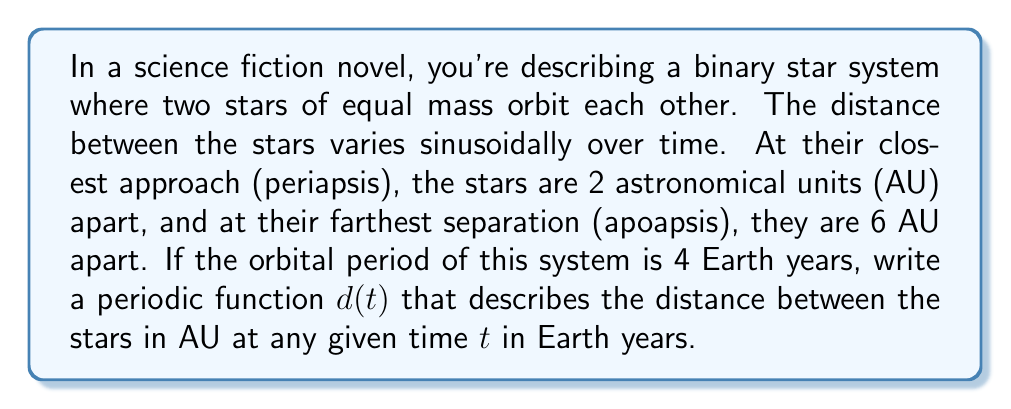Provide a solution to this math problem. To solve this problem, we need to construct a sinusoidal function that represents the distance between the stars over time. Let's approach this step-by-step:

1) The general form of a sinusoidal function is:
   $$d(t) = A \sin(\omega t + \phi) + B$$
   where $A$ is the amplitude, $\omega$ is the angular frequency, $\phi$ is the phase shift, and $B$ is the vertical shift.

2) First, let's determine the vertical shift $B$. This is the midpoint between the maximum and minimum distances:
   $$B = \frac{6 + 2}{2} = 4$$

3) The amplitude $A$ is half the difference between the maximum and minimum distances:
   $$A = \frac{6 - 2}{2} = 2$$

4) The period of the function is 4 years. For a sine function, the period is given by $\frac{2\pi}{\omega}$. So:
   $$\frac{2\pi}{\omega} = 4$$
   $$\omega = \frac{\pi}{2}$$

5) We don't need a phase shift for this problem, so $\phi = 0$.

6) Putting it all together, our function is:
   $$d(t) = 2 \sin(\frac{\pi}{2}t) + 4$$

7) To verify:
   - When $t = 0$, $d(0) = 2 \sin(0) + 4 = 4$ AU
   - When $t = 1$, $d(1) = 2 \sin(\frac{\pi}{2}) + 4 = 6$ AU (apoapsis)
   - When $t = 2$, $d(2) = 2 \sin(\pi) + 4 = 4$ AU
   - When $t = 3$, $d(3) = 2 \sin(\frac{3\pi}{2}) + 4 = 2$ AU (periapsis)
   - When $t = 4$, $d(4) = 2 \sin(2\pi) + 4 = 4$ AU

This function correctly models the orbital behavior of the binary star system as described.
Answer: $$d(t) = 2 \sin(\frac{\pi}{2}t) + 4$$
where $d$ is the distance in AU and $t$ is the time in Earth years. 